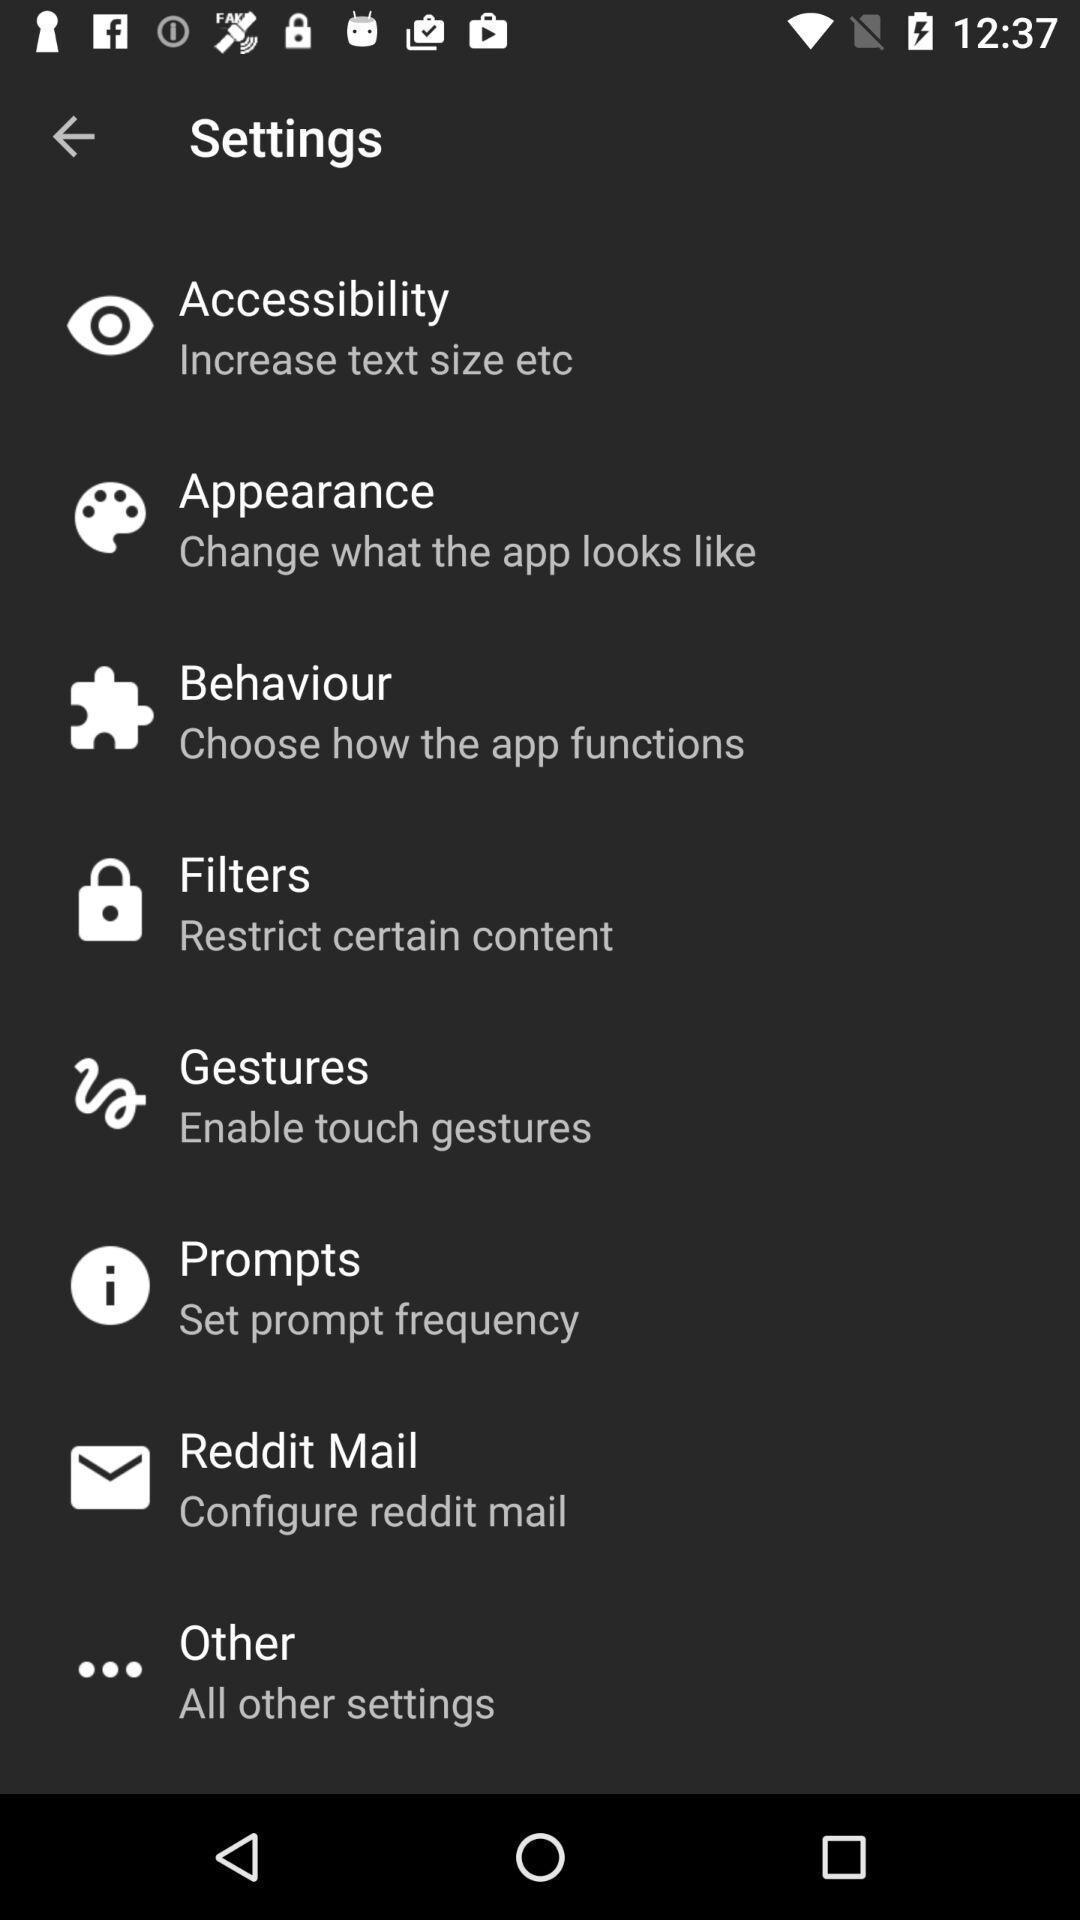Provide a textual representation of this image. Settings page displayed. 